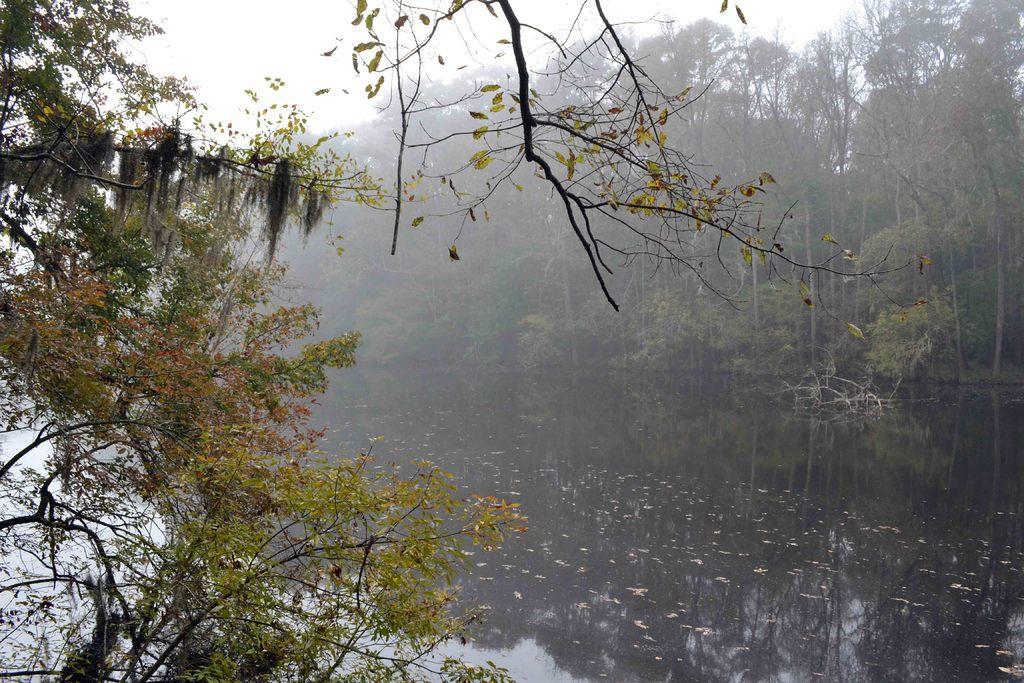In one or two sentences, can you explain what this image depicts? In this image I can see water and number of trees. I can also see reflection of trees in water. 